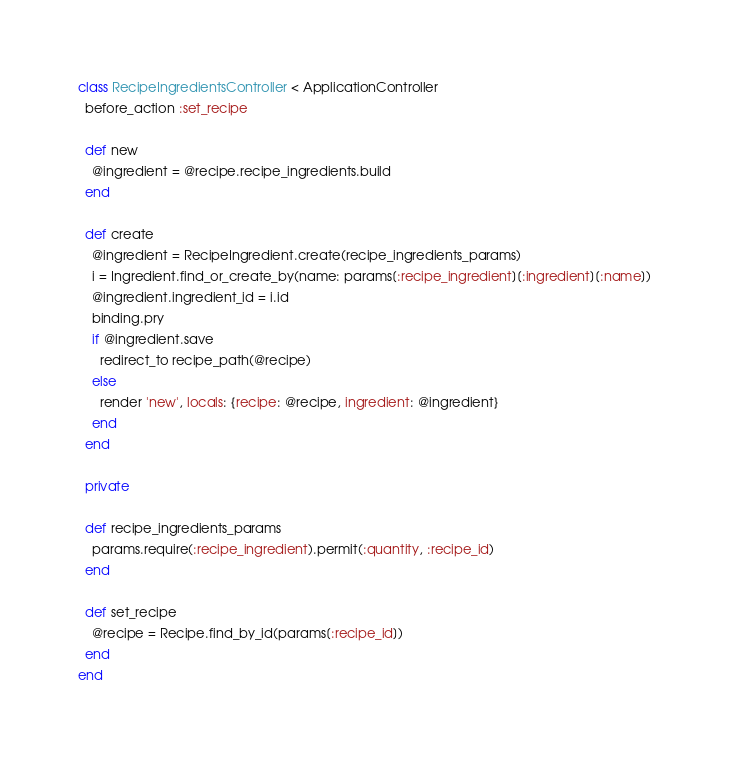Convert code to text. <code><loc_0><loc_0><loc_500><loc_500><_Ruby_>class RecipeIngredientsController < ApplicationController
  before_action :set_recipe

  def new
    @ingredient = @recipe.recipe_ingredients.build
  end

  def create
    @ingredient = RecipeIngredient.create(recipe_ingredients_params)
    i = Ingredient.find_or_create_by(name: params[:recipe_ingredient][:ingredient][:name])
    @ingredient.ingredient_id = i.id
    binding.pry
    if @ingredient.save
      redirect_to recipe_path(@recipe)
    else
      render 'new', locals: {recipe: @recipe, ingredient: @ingredient}
    end
  end

  private

  def recipe_ingredients_params
    params.require(:recipe_ingredient).permit(:quantity, :recipe_id)
  end

  def set_recipe
    @recipe = Recipe.find_by_id(params[:recipe_id])
  end
end
</code> 